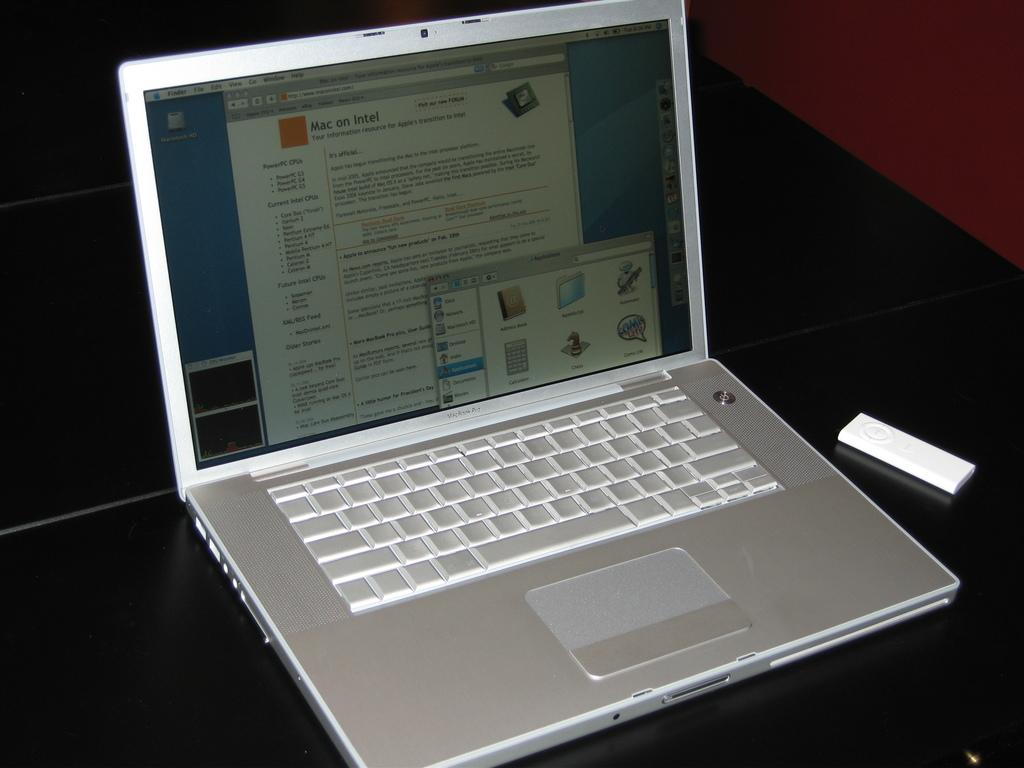What electronic device is present in the image? There is a laptop in the image. What color is the object next to the laptop? There is a white object in the image. What can be seen on the laptop screen? There is text visible on the laptop screen. Where is the drawer located in the image? There is no drawer present in the image. What type of engine is visible in the image? There is no engine present in the image. 